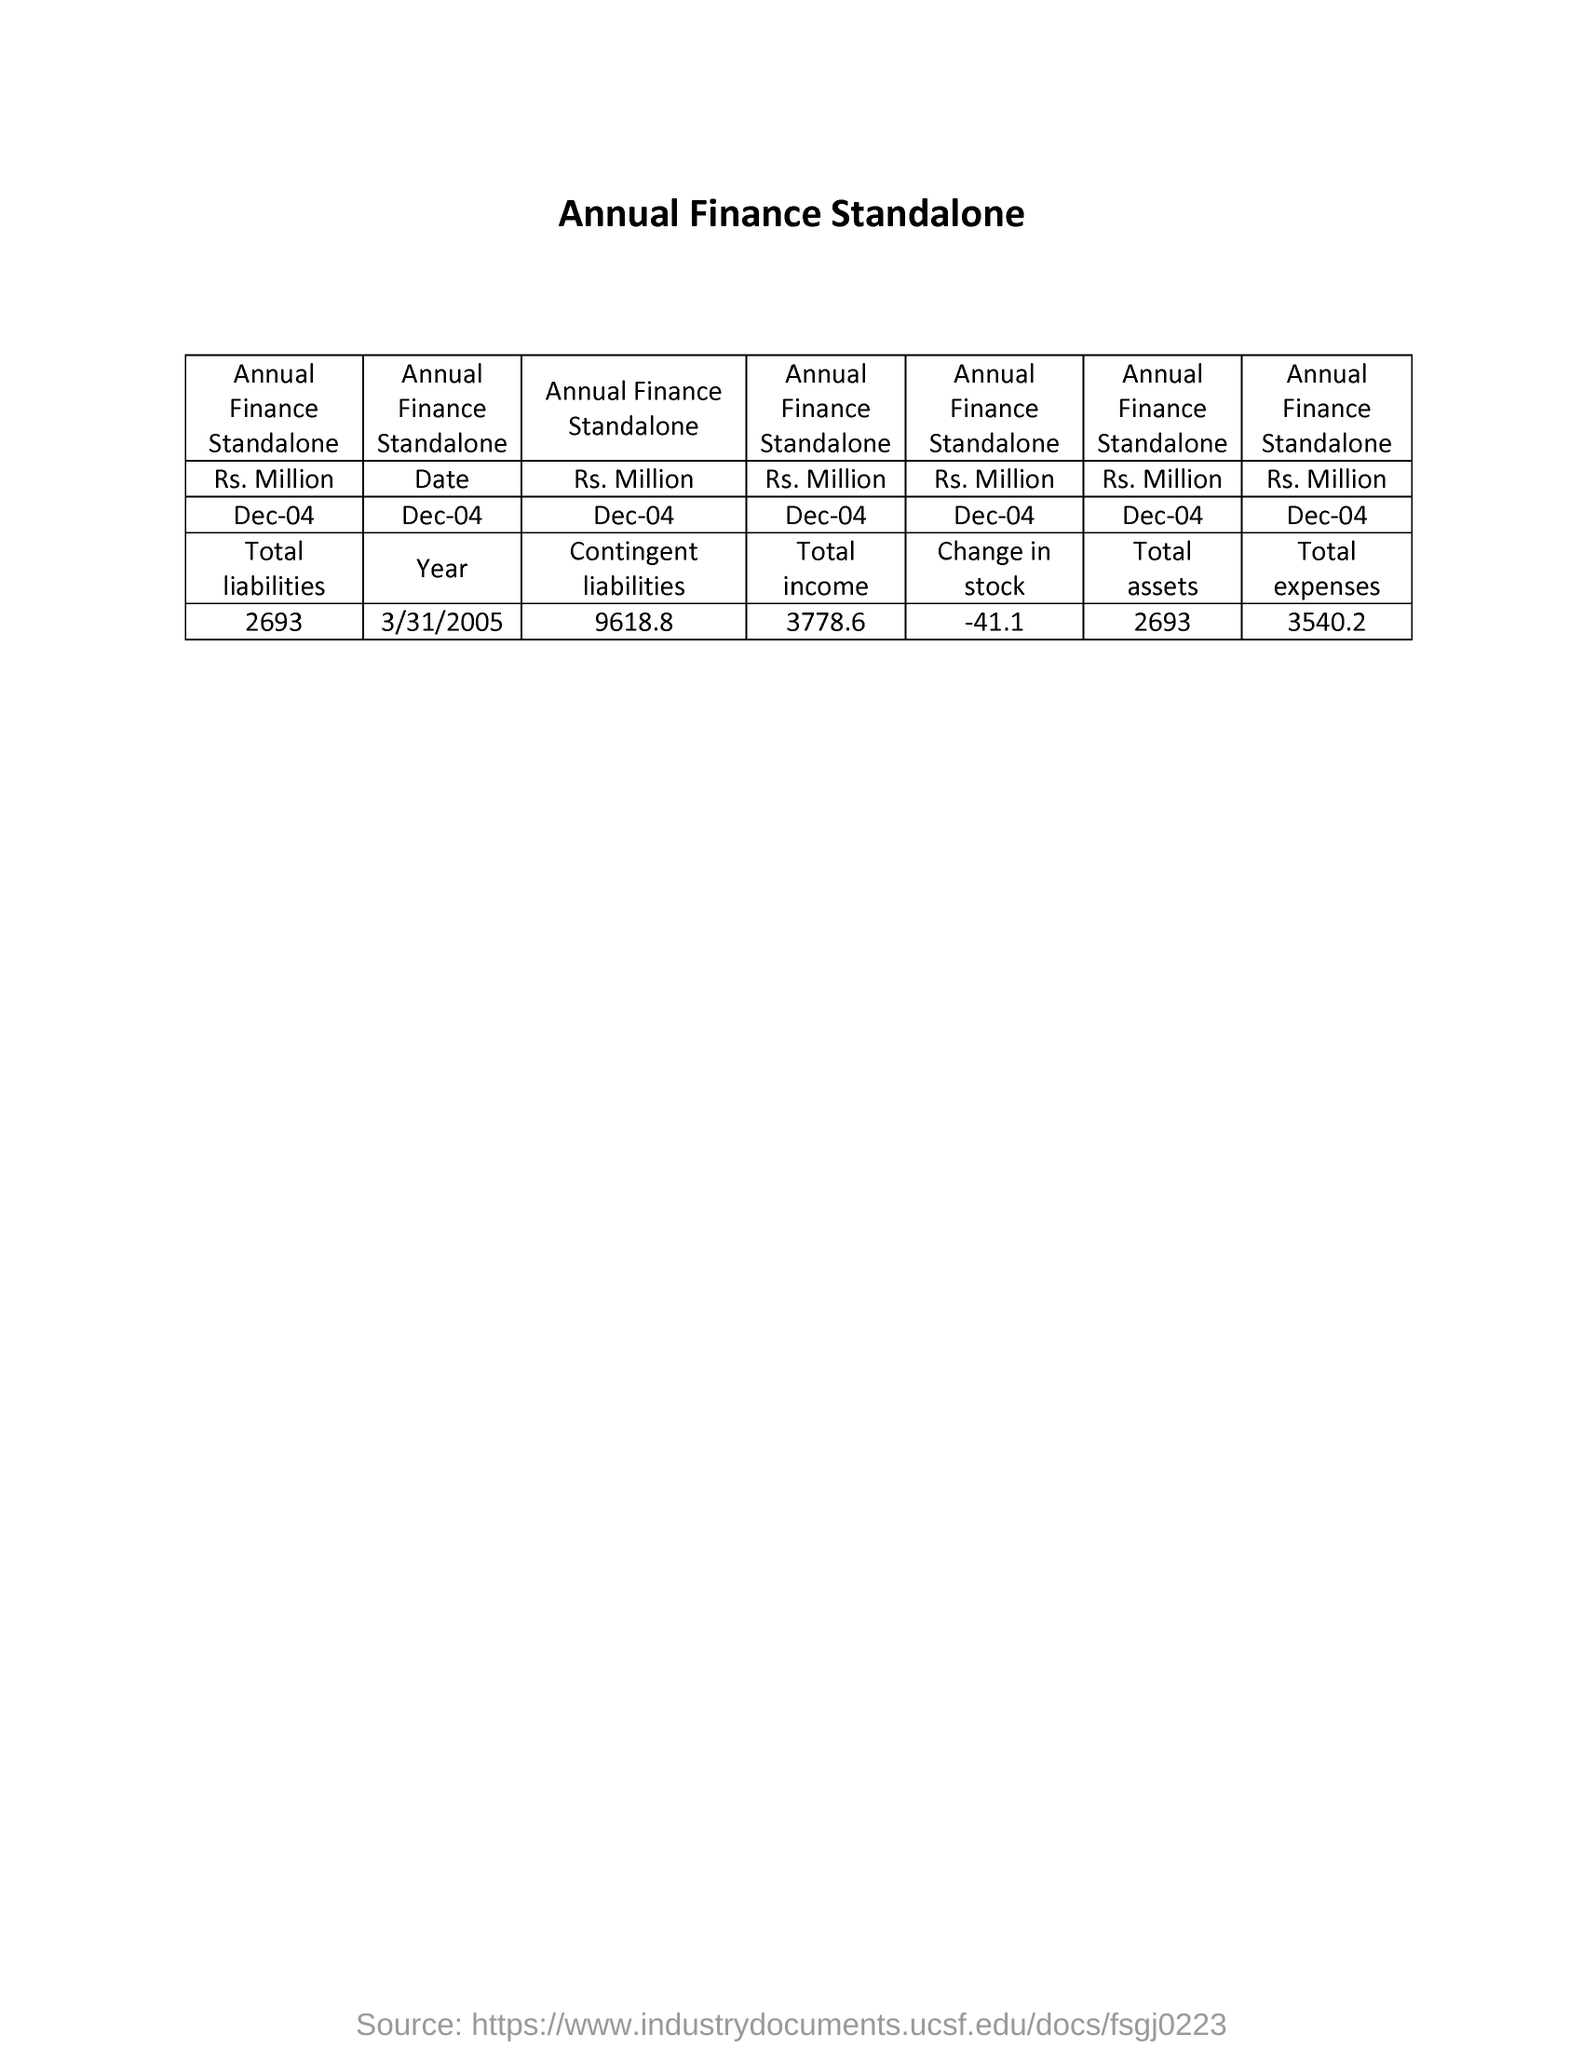What is the total liabilities of  annual finance standalone  rs million as on dec-04 ?
Your response must be concise. 2693. What is the contingent  liabilities of  annual finance standalone  rs million as on dec-04
Give a very brief answer. 9618.8. What is the total income  of  annual finance standalone  rs million as on dec-04
Make the answer very short. 3778.6. What is the change in stock of  annual finance standalone  rs million as on dec-04
Provide a short and direct response. -41.1. What is the total assets of  annual finance standalone  rs million as on dec-04
Make the answer very short. 2693. What is the total expenses of  annual finance standalone  rs million as on dec-04
Ensure brevity in your answer.  3540.2. 